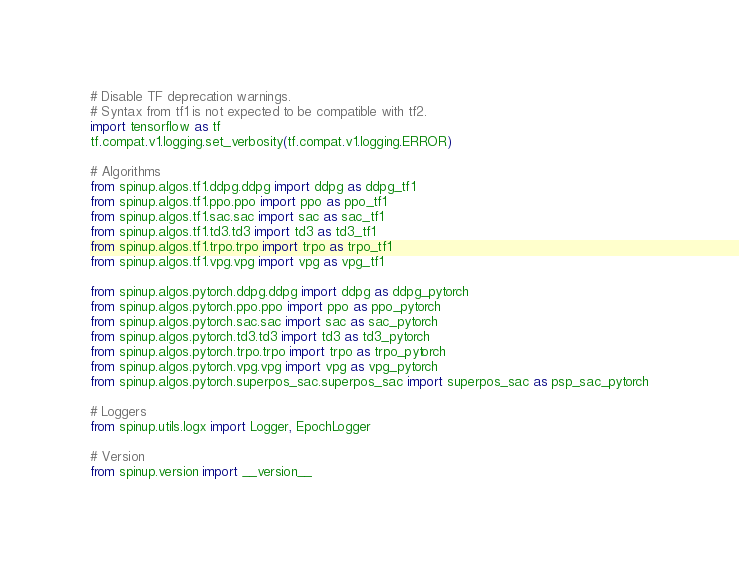<code> <loc_0><loc_0><loc_500><loc_500><_Python_># Disable TF deprecation warnings.
# Syntax from tf1 is not expected to be compatible with tf2.
import tensorflow as tf
tf.compat.v1.logging.set_verbosity(tf.compat.v1.logging.ERROR)

# Algorithms
from spinup.algos.tf1.ddpg.ddpg import ddpg as ddpg_tf1
from spinup.algos.tf1.ppo.ppo import ppo as ppo_tf1
from spinup.algos.tf1.sac.sac import sac as sac_tf1
from spinup.algos.tf1.td3.td3 import td3 as td3_tf1
from spinup.algos.tf1.trpo.trpo import trpo as trpo_tf1
from spinup.algos.tf1.vpg.vpg import vpg as vpg_tf1

from spinup.algos.pytorch.ddpg.ddpg import ddpg as ddpg_pytorch
from spinup.algos.pytorch.ppo.ppo import ppo as ppo_pytorch
from spinup.algos.pytorch.sac.sac import sac as sac_pytorch
from spinup.algos.pytorch.td3.td3 import td3 as td3_pytorch
from spinup.algos.pytorch.trpo.trpo import trpo as trpo_pytorch
from spinup.algos.pytorch.vpg.vpg import vpg as vpg_pytorch
from spinup.algos.pytorch.superpos_sac.superpos_sac import superpos_sac as psp_sac_pytorch

# Loggers
from spinup.utils.logx import Logger, EpochLogger

# Version
from spinup.version import __version__</code> 